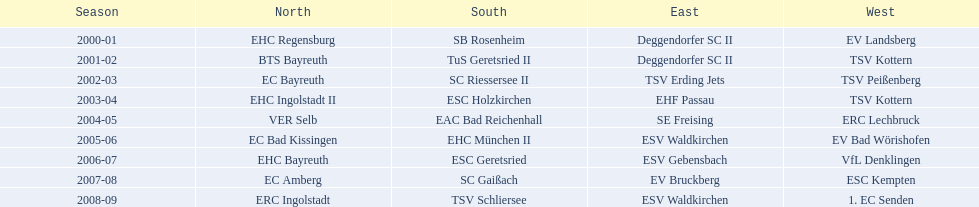Which teams won the north in their respective years? 2000-01, EHC Regensburg, BTS Bayreuth, EC Bayreuth, EHC Ingolstadt II, VER Selb, EC Bad Kissingen, EHC Bayreuth, EC Amberg, ERC Ingolstadt. Which one only won in 2000-01? EHC Regensburg. 